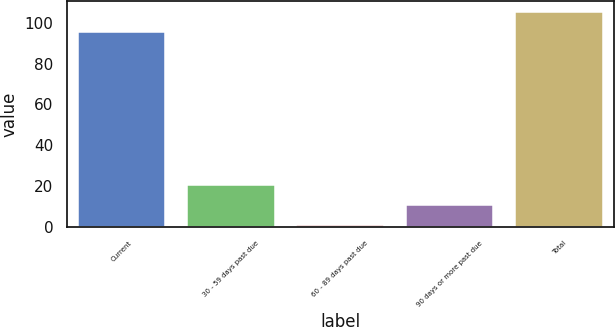Convert chart to OTSL. <chart><loc_0><loc_0><loc_500><loc_500><bar_chart><fcel>Current<fcel>30 - 59 days past due<fcel>60 - 89 days past due<fcel>90 days or more past due<fcel>Total<nl><fcel>95.3<fcel>20.56<fcel>0.7<fcel>10.63<fcel>105.23<nl></chart> 